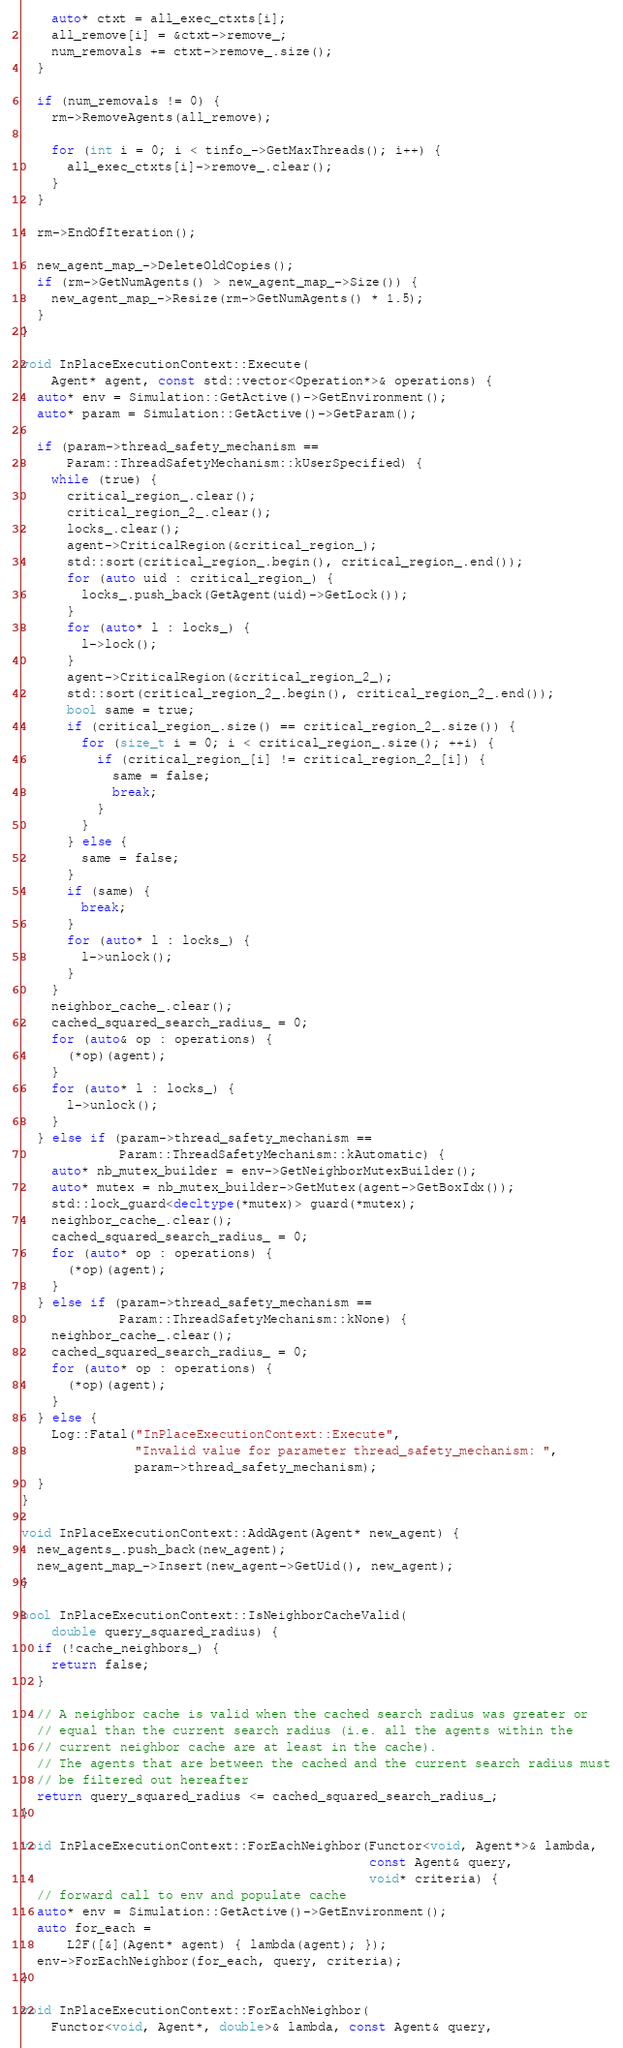<code> <loc_0><loc_0><loc_500><loc_500><_C++_>    auto* ctxt = all_exec_ctxts[i];
    all_remove[i] = &ctxt->remove_;
    num_removals += ctxt->remove_.size();
  }

  if (num_removals != 0) {
    rm->RemoveAgents(all_remove);

    for (int i = 0; i < tinfo_->GetMaxThreads(); i++) {
      all_exec_ctxts[i]->remove_.clear();
    }
  }

  rm->EndOfIteration();

  new_agent_map_->DeleteOldCopies();
  if (rm->GetNumAgents() > new_agent_map_->Size()) {
    new_agent_map_->Resize(rm->GetNumAgents() * 1.5);
  }
}

void InPlaceExecutionContext::Execute(
    Agent* agent, const std::vector<Operation*>& operations) {
  auto* env = Simulation::GetActive()->GetEnvironment();
  auto* param = Simulation::GetActive()->GetParam();

  if (param->thread_safety_mechanism ==
      Param::ThreadSafetyMechanism::kUserSpecified) {
    while (true) {
      critical_region_.clear();
      critical_region_2_.clear();
      locks_.clear();
      agent->CriticalRegion(&critical_region_);
      std::sort(critical_region_.begin(), critical_region_.end());
      for (auto uid : critical_region_) {
        locks_.push_back(GetAgent(uid)->GetLock());
      }
      for (auto* l : locks_) {
        l->lock();
      }
      agent->CriticalRegion(&critical_region_2_);
      std::sort(critical_region_2_.begin(), critical_region_2_.end());
      bool same = true;
      if (critical_region_.size() == critical_region_2_.size()) {
        for (size_t i = 0; i < critical_region_.size(); ++i) {
          if (critical_region_[i] != critical_region_2_[i]) {
            same = false;
            break;
          }
        }
      } else {
        same = false;
      }
      if (same) {
        break;
      }
      for (auto* l : locks_) {
        l->unlock();
      }
    }
    neighbor_cache_.clear();
    cached_squared_search_radius_ = 0;
    for (auto& op : operations) {
      (*op)(agent);
    }
    for (auto* l : locks_) {
      l->unlock();
    }
  } else if (param->thread_safety_mechanism ==
             Param::ThreadSafetyMechanism::kAutomatic) {
    auto* nb_mutex_builder = env->GetNeighborMutexBuilder();
    auto* mutex = nb_mutex_builder->GetMutex(agent->GetBoxIdx());
    std::lock_guard<decltype(*mutex)> guard(*mutex);
    neighbor_cache_.clear();
    cached_squared_search_radius_ = 0;
    for (auto* op : operations) {
      (*op)(agent);
    }
  } else if (param->thread_safety_mechanism ==
             Param::ThreadSafetyMechanism::kNone) {
    neighbor_cache_.clear();
    cached_squared_search_radius_ = 0;
    for (auto* op : operations) {
      (*op)(agent);
    }
  } else {
    Log::Fatal("InPlaceExecutionContext::Execute",
               "Invalid value for parameter thread_safety_mechanism: ",
               param->thread_safety_mechanism);
  }
}

void InPlaceExecutionContext::AddAgent(Agent* new_agent) {
  new_agents_.push_back(new_agent);
  new_agent_map_->Insert(new_agent->GetUid(), new_agent);
}

bool InPlaceExecutionContext::IsNeighborCacheValid(
    double query_squared_radius) {
  if (!cache_neighbors_) {
    return false;
  }

  // A neighbor cache is valid when the cached search radius was greater or
  // equal than the current search radius (i.e. all the agents within the
  // current neighbor cache are at least in the cache).
  // The agents that are between the cached and the current search radius must
  // be filtered out hereafter
  return query_squared_radius <= cached_squared_search_radius_;
}

void InPlaceExecutionContext::ForEachNeighbor(Functor<void, Agent*>& lambda,
                                              const Agent& query,
                                              void* criteria) {
  // forward call to env and populate cache
  auto* env = Simulation::GetActive()->GetEnvironment();
  auto for_each =
      L2F([&](Agent* agent) { lambda(agent); });
  env->ForEachNeighbor(for_each, query, criteria);
}

void InPlaceExecutionContext::ForEachNeighbor(
    Functor<void, Agent*, double>& lambda, const Agent& query,</code> 